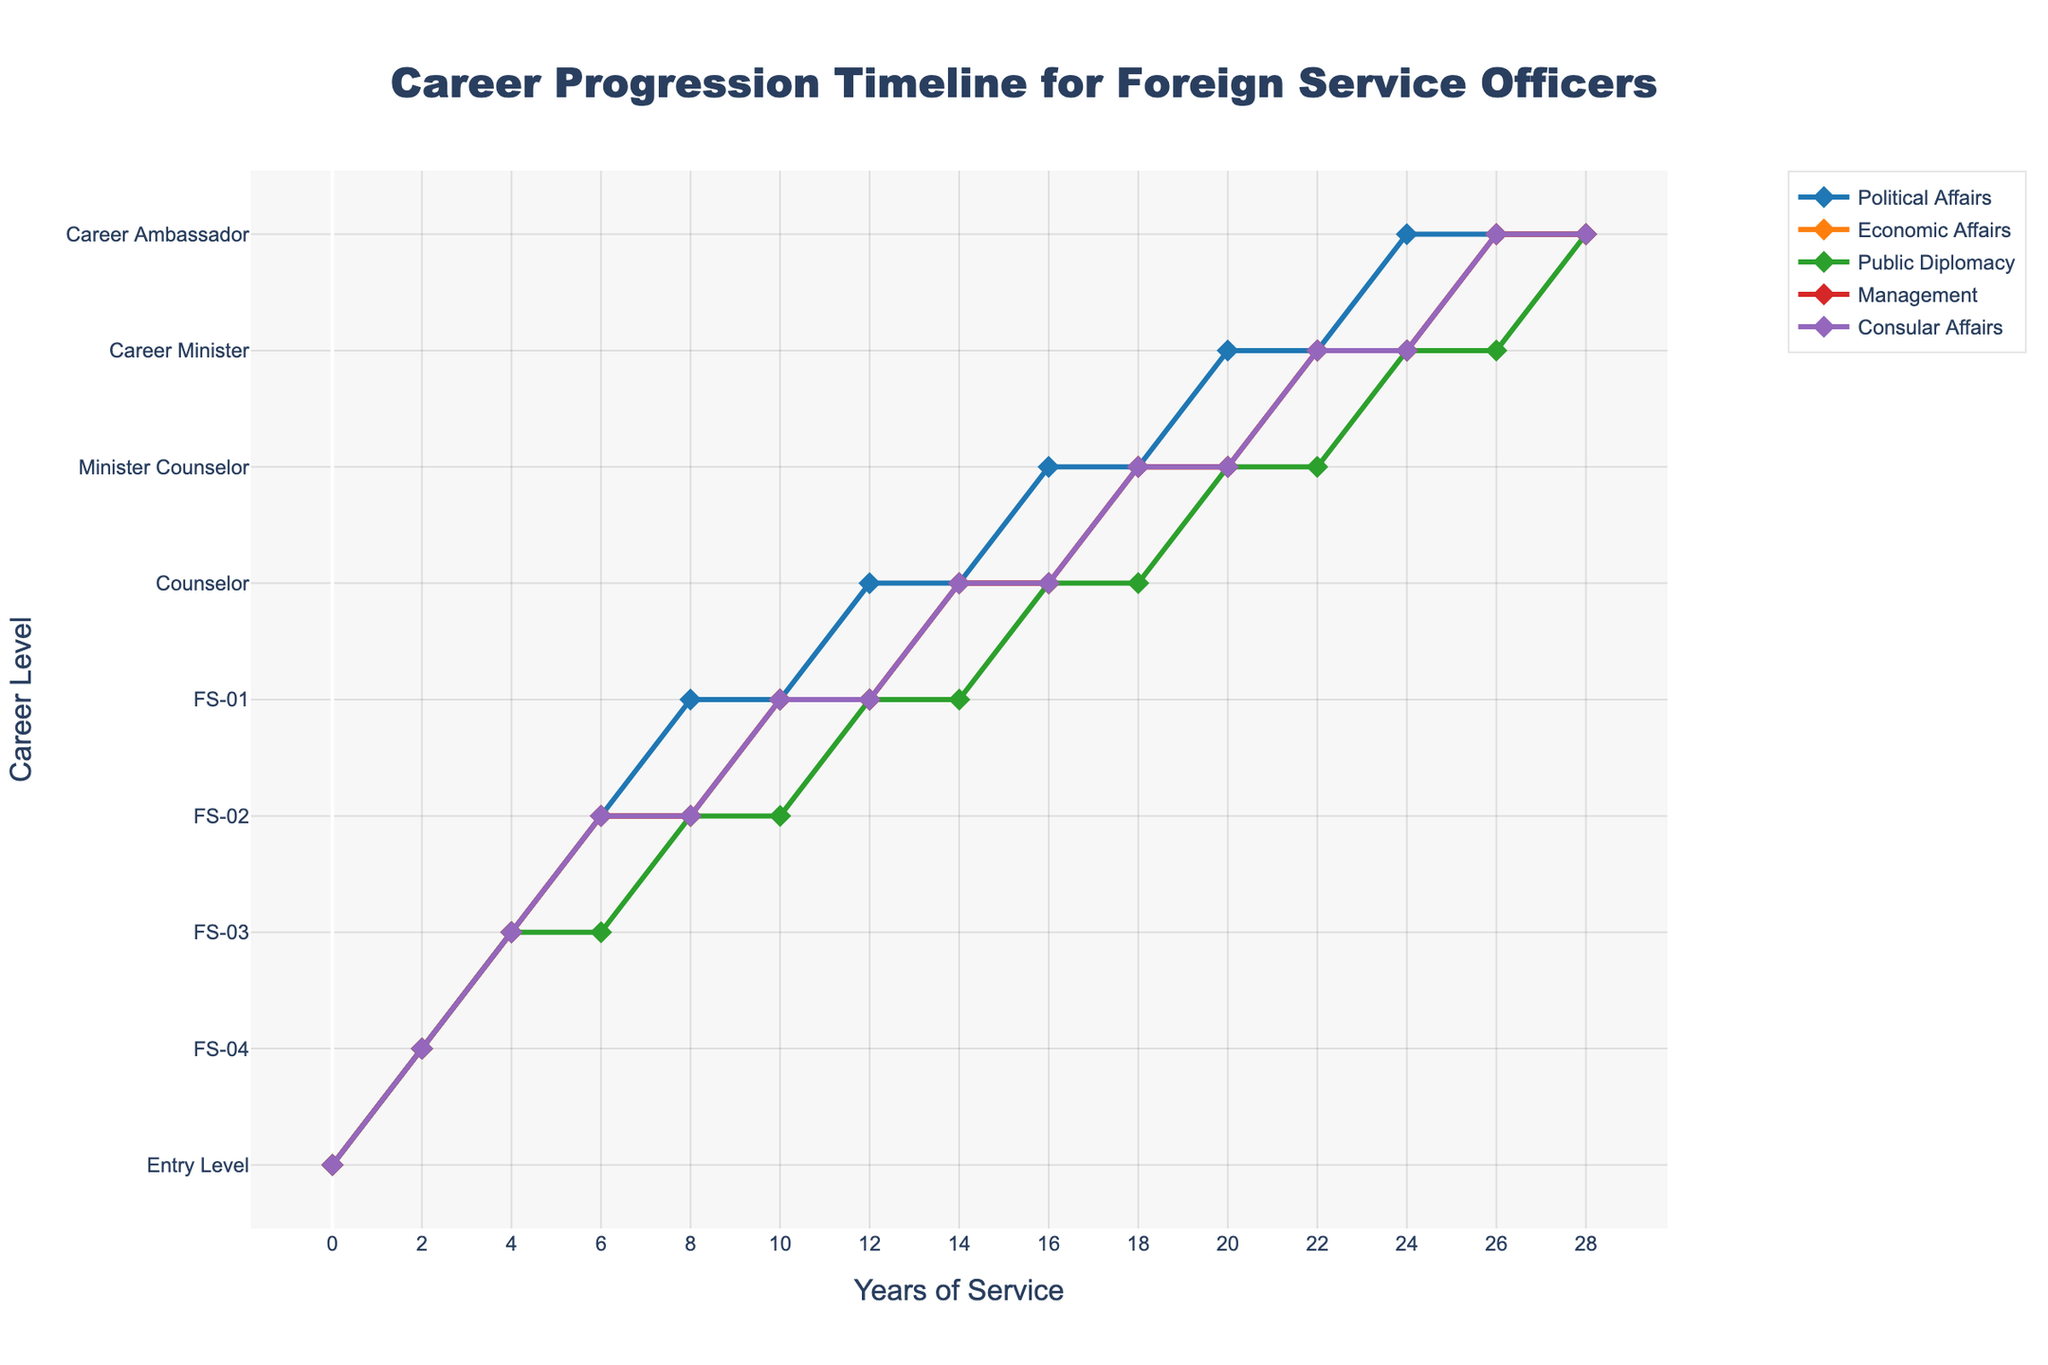How long does it take for someone in Political Affairs to reach Counselor level? Look at the Political Affairs line and find the point labeled "Counselor." It is at year 12.
Answer: 12 years Which specialization reaches the Minister Counselor level first, and in what year? Compare the lines for all specializations to determine the first appearance of "Minister Counselor." Political Affairs reaches it first at year 16.
Answer: Political Affairs, year 16 By year 8, which career levels have been achieved by most specializations? Examine the lines at year 8. Most specializations are at the FS-02 level.
Answer: FS-02 At year 20, which specializations are at the Career Minister level? Check the plot at year 20 to see which lines are labeled "Career Minister." Political Affairs and Public Diplomacy are at Career Minister level.
Answer: Political Affairs, Public Diplomacy How many years does it take for a Consular Affairs officer to progress from FS-04 to FS-02? Find the points where Consular Affairs is labeled "FS-04" and "FS-02." This change occurs from year 2 to year 4.
Answer: 2 years Which specialization experiences the fastest career progression from FS-03 to FS-01? Look for the shortest time span between FS-03 and FS-01 for each specialization. Political Affairs transitions from FS-03 at year 4 to FS-01 at year 8, in comparison to others.
Answer: Political Affairs How many specializations are at the Career Ambassador level by year 28? Identify all the specialization lines at year 28 that are labeled "Career Ambassador." All five specializations are at this level.
Answer: 5 Compare the career levels of Economic Affairs and Management at year 12. Which one is at a higher level? Check the levels labeled for Economic Affairs and Management at year 12. Economic Affairs is at FS-01, whereas Management is also at FS-01. The levels are the same.
Answer: Same level What is the average time taken to reach FS-01 level for the Management and Consular Affairs specializations? Calculate the years for Management (year 10) and Consular Affairs (year 10) to reach FS-01, then average them: (10+10)/2 = 10 years.
Answer: 10 years At which career level do Public Diplomacy officers start to lag behind the others? Find the first occurrence where Public Diplomacy's career level is lower than the others at a given year. This happens at year 6, where other specializations reach FS-02 and Public Diplomacy remains at FS-03.
Answer: FS-03, year 6 